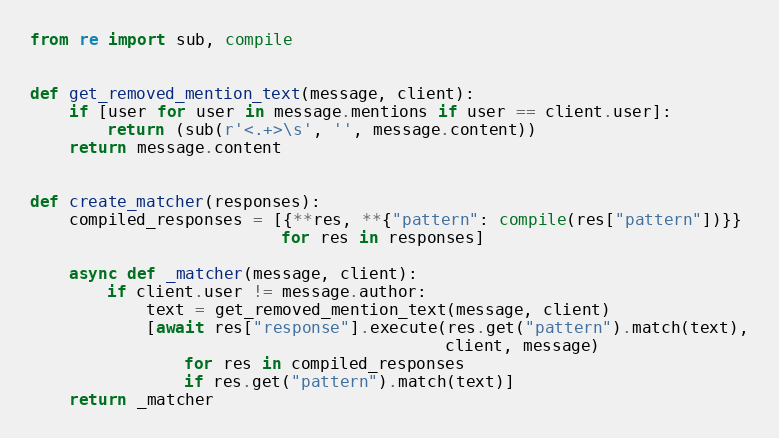Convert code to text. <code><loc_0><loc_0><loc_500><loc_500><_Python_>from re import sub, compile


def get_removed_mention_text(message, client):
    if [user for user in message.mentions if user == client.user]:
        return (sub(r'<.+>\s', '', message.content))
    return message.content


def create_matcher(responses):
    compiled_responses = [{**res, **{"pattern": compile(res["pattern"])}}
                          for res in responses]

    async def _matcher(message, client):
        if client.user != message.author:
            text = get_removed_mention_text(message, client)
            [await res["response"].execute(res.get("pattern").match(text),
                                           client, message)
                for res in compiled_responses
                if res.get("pattern").match(text)]
    return _matcher
</code> 